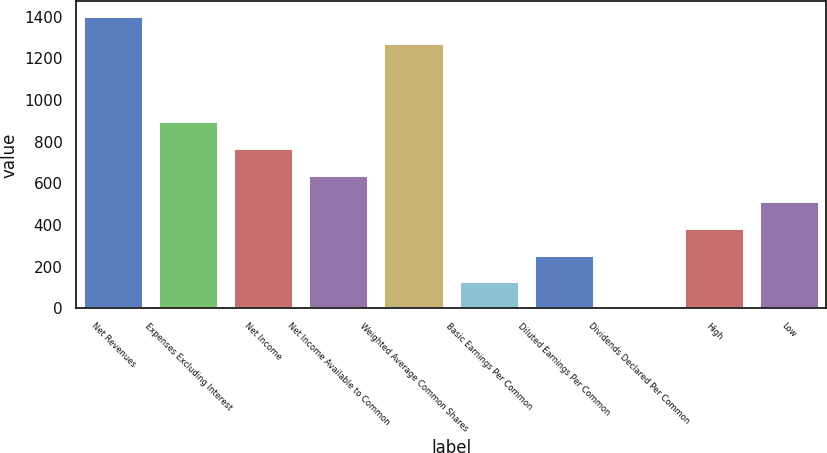<chart> <loc_0><loc_0><loc_500><loc_500><bar_chart><fcel>Net Revenues<fcel>Expenses Excluding Interest<fcel>Net Income<fcel>Net Income Available to Common<fcel>Weighted Average Common Shares<fcel>Basic Earnings Per Common<fcel>Diluted Earnings Per Common<fcel>Dividends Declared Per Common<fcel>High<fcel>Low<nl><fcel>1402.29<fcel>898.09<fcel>769.8<fcel>641.51<fcel>1274<fcel>128.35<fcel>256.64<fcel>0.06<fcel>384.93<fcel>513.22<nl></chart> 